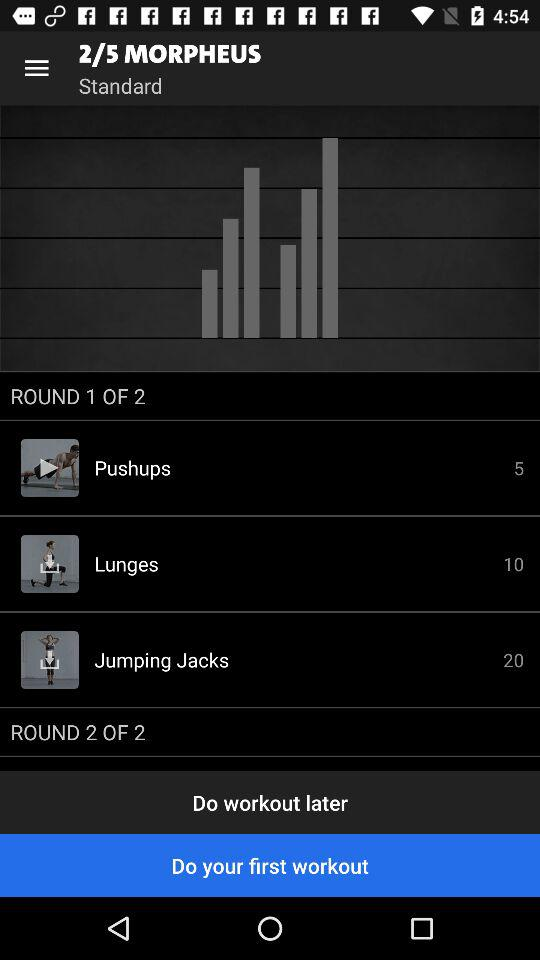What is the number of jumping jacks? The number of jumping jacks is 20. 